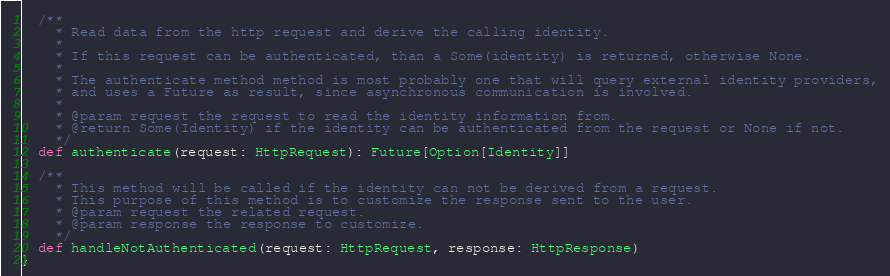<code> <loc_0><loc_0><loc_500><loc_500><_Scala_>
  /**
    * Read data from the http request and derive the calling identity.
    *
    * If this request can be authenticated, than a Some(identity) is returned, otherwise None.
    *
    * The authenticate method method is most probably one that will query external identity providers,
    * and uses a Future as result, since asynchronous communication is involved.
    *
    * @param request the request to read the identity information from.
    * @return Some(Identity) if the identity can be authenticated from the request or None if not.
    */
  def authenticate(request: HttpRequest): Future[Option[Identity]]

  /**
    * This method will be called if the identity can not be derived from a request.
    * This purpose of this method is to customize the response sent to the user.
    * @param request the related request.
    * @param response the response to customize.
    */
  def handleNotAuthenticated(request: HttpRequest, response: HttpResponse)
}

</code> 